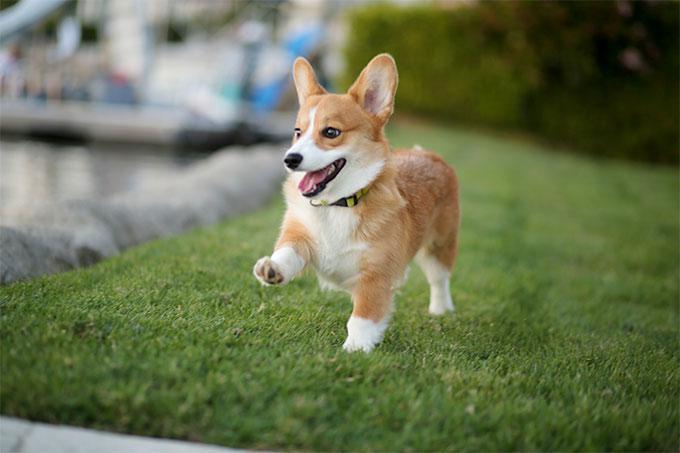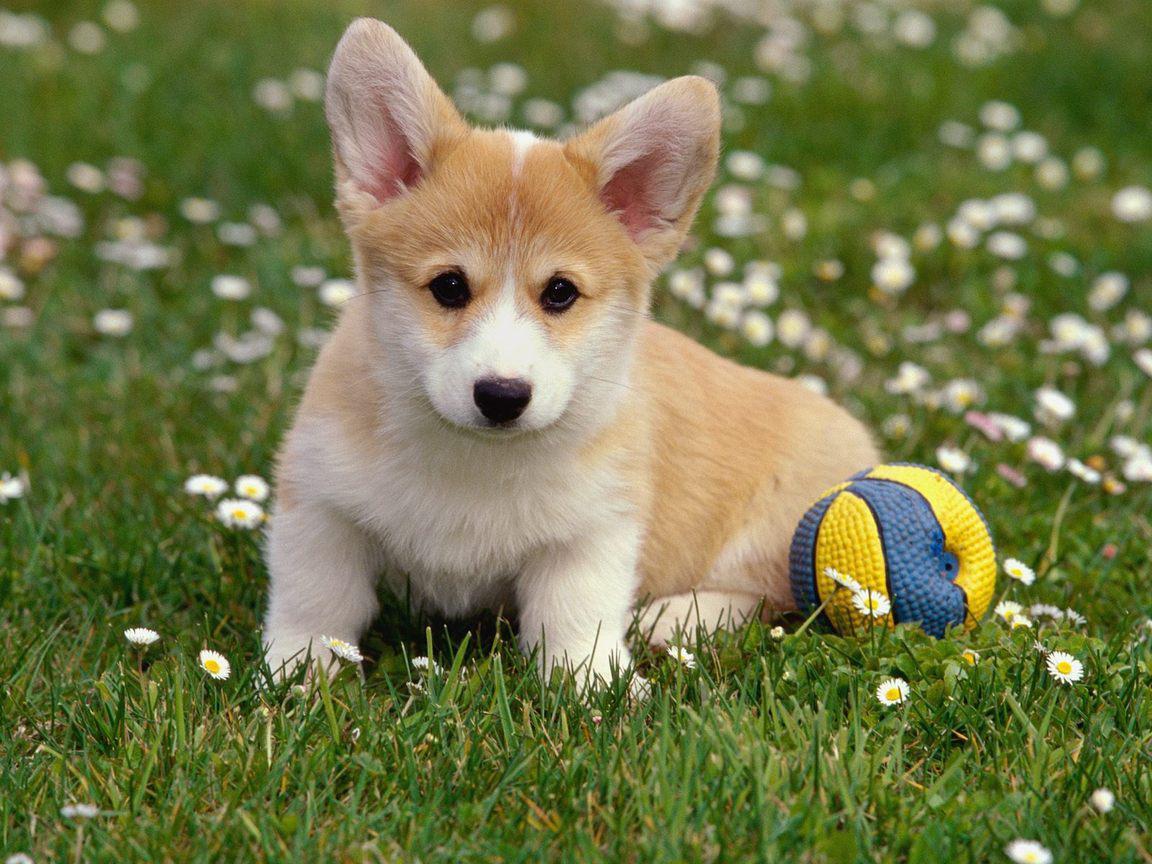The first image is the image on the left, the second image is the image on the right. Given the left and right images, does the statement "In the image on the right, a dog rests among some flowers." hold true? Answer yes or no. Yes. The first image is the image on the left, the second image is the image on the right. Analyze the images presented: Is the assertion "The image on the right shows a corgi puppy in the middle of a grassy area with flowers." valid? Answer yes or no. Yes. 